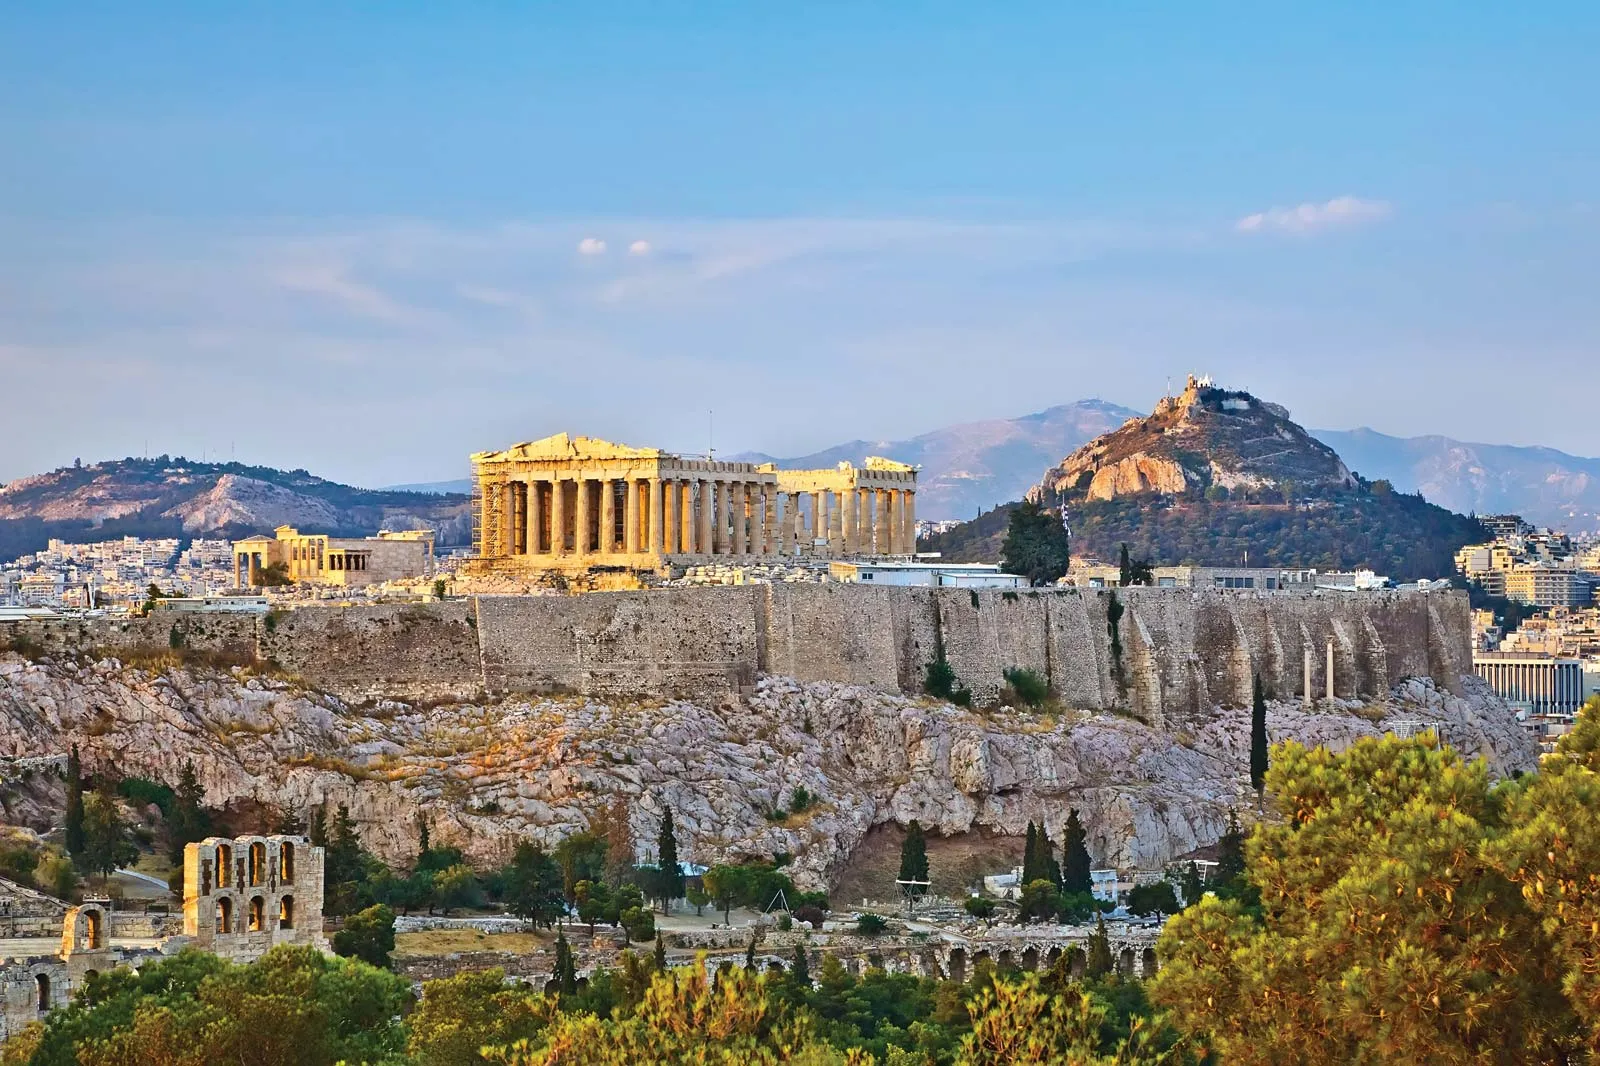Can you tell me more about the historical significance of this place? The Acropolis of Athens is an ancient citadel that holds immense historical significance. It symbolizes the cultural and political success of the Athenian empire during its golden age in the 5th century BCE. Built primarily under the leadership of Pericles, the Acropolis showcases the brilliance of ancient Greek architecture and art. The Parthenon, dedicated to Athena, the city's patron goddess, is considered an architectural marvel. Historically, the Acropolis served as a focal point for both religious and civic festivities and remains one of the most significant heritage sites, attracting scholars, historians, and tourists from around the world. What is a lesser-known fact about the Acropolis? A lesser-known fact about the Acropolis is that the Parthenon was used as a treasury. It housed the Delian League's treasury, which played a vital role in financing the Athenian empire's monumental building projects and military endeavors. This aspect highlights the Parthenon not only as a religious temple but also as a symbol of Athenian economic and political power during its peak. Can you imagine what life was like around the Acropolis in ancient times? Ancient Athens, under the shadow of the Acropolis, would have been a bustling city filled with philosophers, artists, and citizens deeply engaged in the democratic processes. The Agora, a busy marketplace and civic center, would be abuzz with traders, orators, and scholars exchanging ideas. Religious rituals and grandiose festivals, especially those dedicated to Athena, would frequently take place, drawing large crowds. The streets would be lined with elaborate structures, each displaying the architectural grandeur of the time. The air would be filled with the aroma of Mediterranean cuisine, and in the background, the echo of debates and discussions on politics, philosophy, and art would be constant. This vivid tapestry of social, religious, and political activity paints a picture of a thriving and dynamic ancient Greek society. 